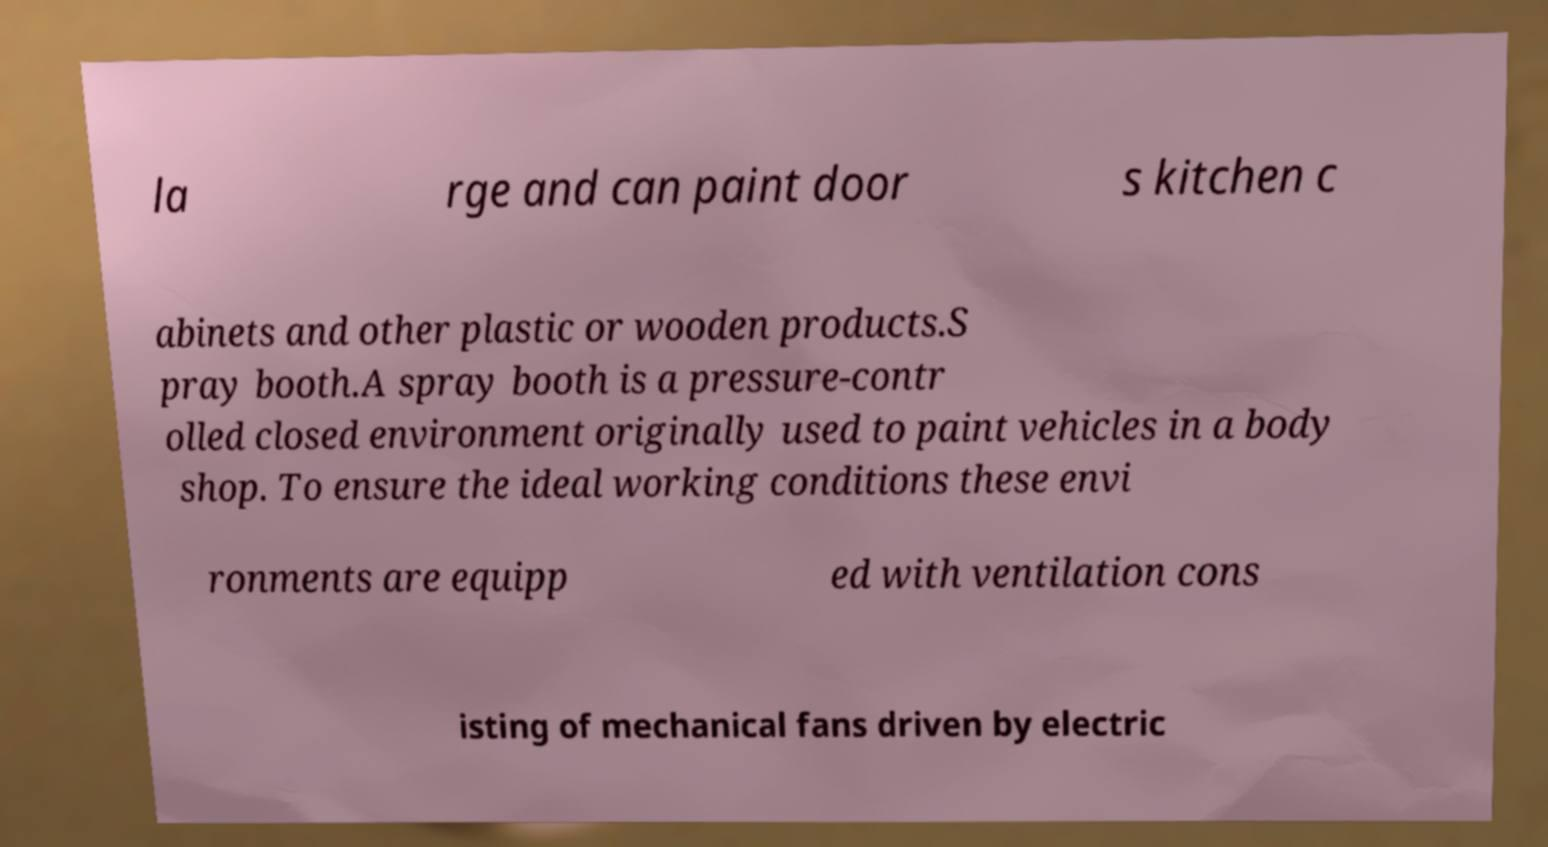Can you accurately transcribe the text from the provided image for me? la rge and can paint door s kitchen c abinets and other plastic or wooden products.S pray booth.A spray booth is a pressure-contr olled closed environment originally used to paint vehicles in a body shop. To ensure the ideal working conditions these envi ronments are equipp ed with ventilation cons isting of mechanical fans driven by electric 